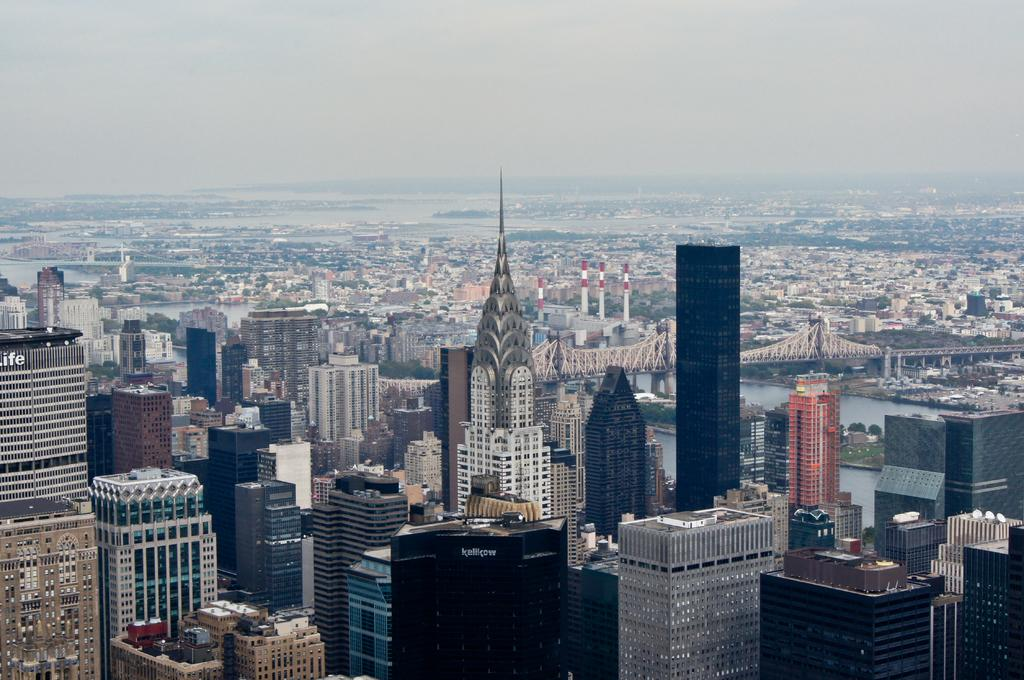What type of structures can be seen in the image? There are many buildings in the image. What is located in the middle of the image? There is a bridge in the middle of the image. What is present alongside the bridge? There is water in the middle of the image. What is visible at the top of the image? The sky is visible at the top of the image. What type of instrument is being played by the authority figure in the image? There is no instrument or authority figure present in the image. What type of jeans are the people wearing in the image? There are no people or jeans visible in the image. 